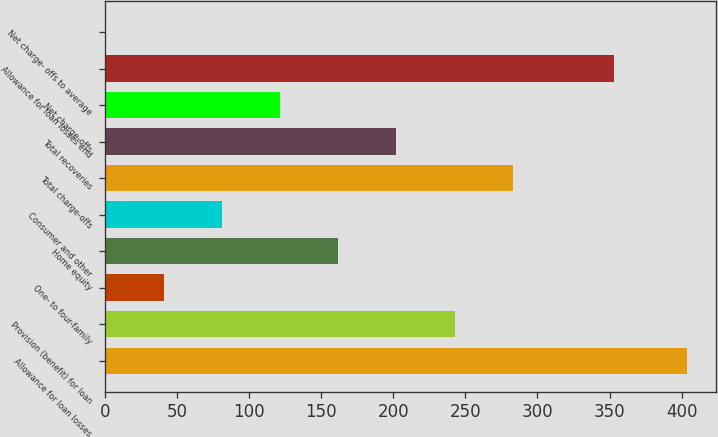<chart> <loc_0><loc_0><loc_500><loc_500><bar_chart><fcel>Allowance for loan losses<fcel>Provision (benefit) for loan<fcel>One- to four-family<fcel>Home equity<fcel>Consumer and other<fcel>Total charge-offs<fcel>Total recoveries<fcel>Net charge-offs<fcel>Allowance for loan losses end<fcel>Net charge- offs to average<nl><fcel>404<fcel>242.48<fcel>40.58<fcel>161.72<fcel>80.96<fcel>282.86<fcel>202.1<fcel>121.34<fcel>353<fcel>0.2<nl></chart> 